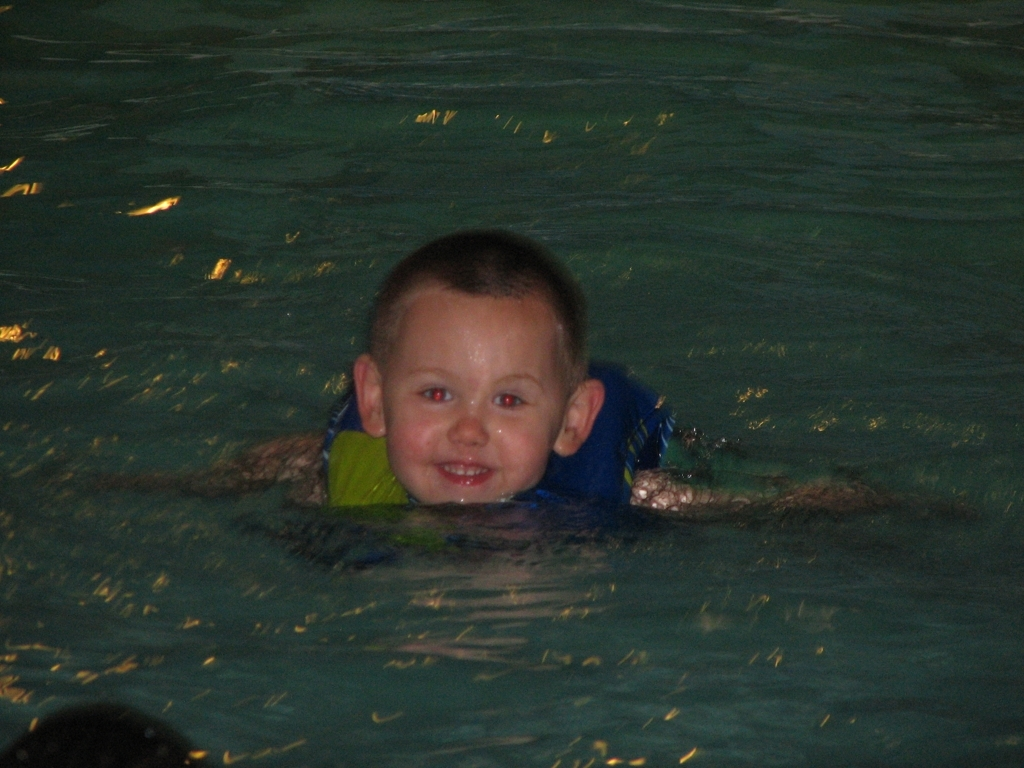What safety precautions should be considered when children are swimming? When children are swimming, it's important to ensure constant adult supervision, use appropriate floatation devices, and make sure the child knows basic water safety rules. 